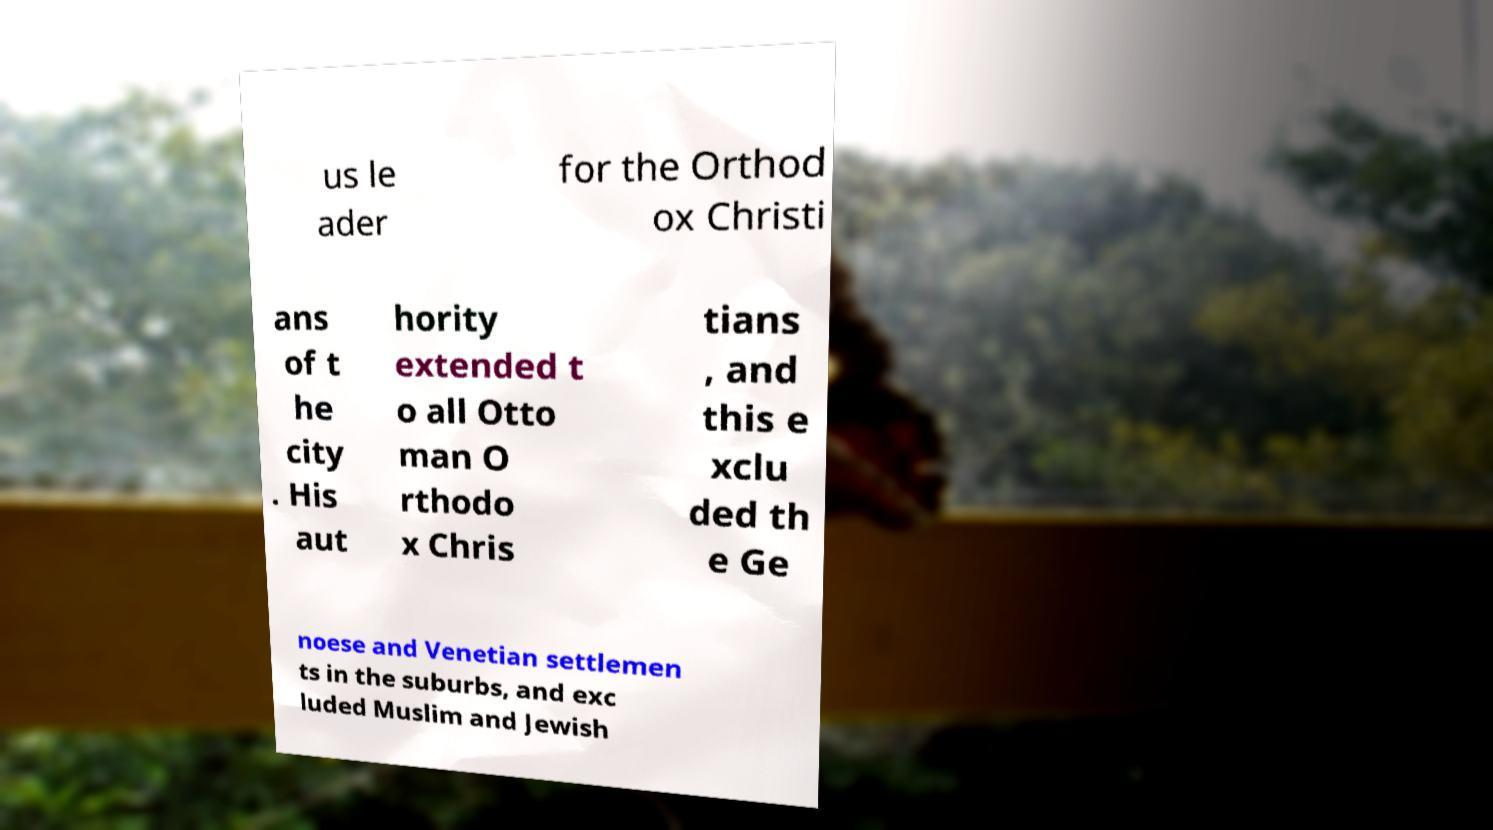Can you accurately transcribe the text from the provided image for me? us le ader for the Orthod ox Christi ans of t he city . His aut hority extended t o all Otto man O rthodo x Chris tians , and this e xclu ded th e Ge noese and Venetian settlemen ts in the suburbs, and exc luded Muslim and Jewish 